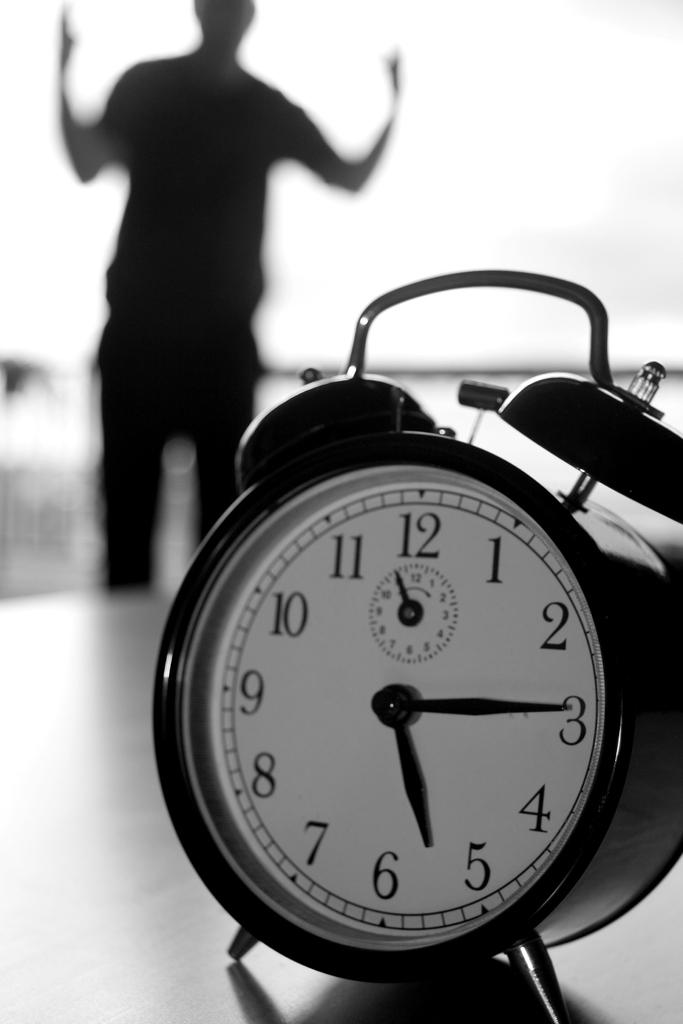<image>
Write a terse but informative summary of the picture. a clock is shown displaying the time of 5:15 